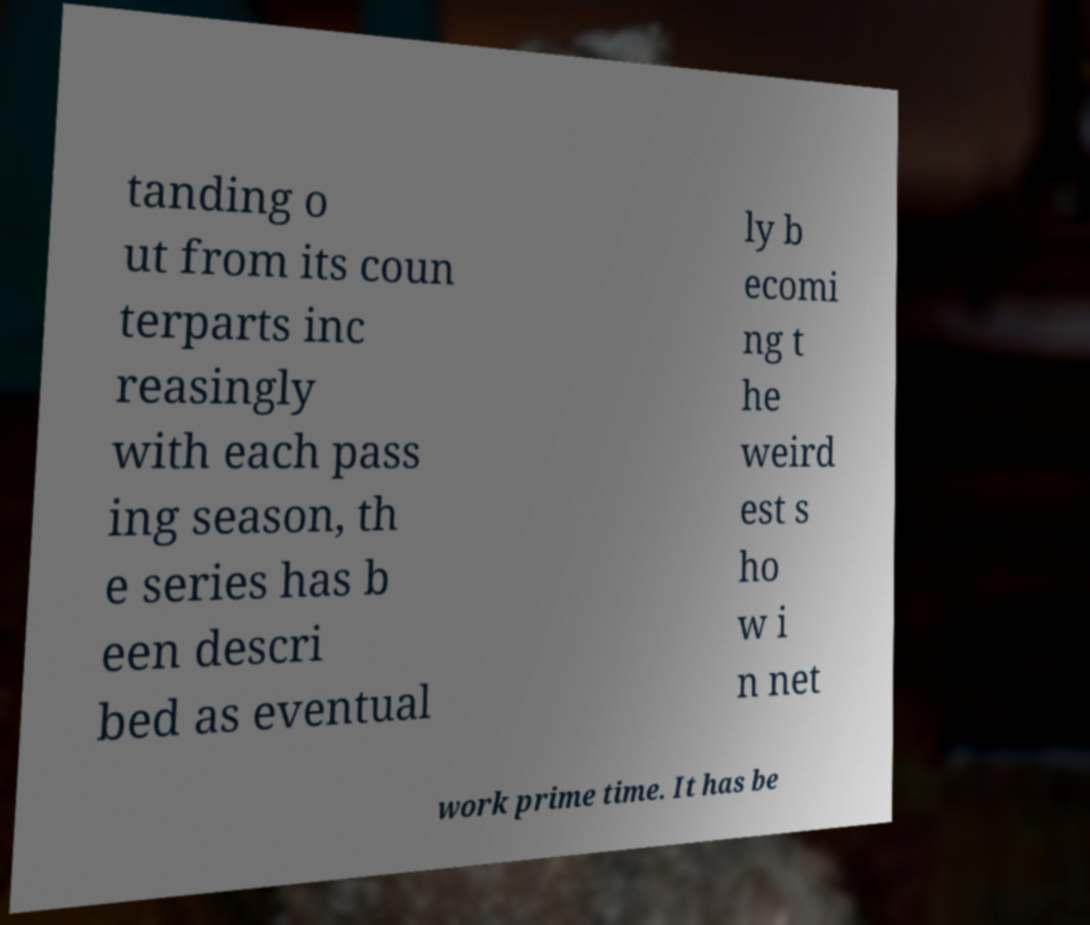Can you accurately transcribe the text from the provided image for me? tanding o ut from its coun terparts inc reasingly with each pass ing season, th e series has b een descri bed as eventual ly b ecomi ng t he weird est s ho w i n net work prime time. It has be 